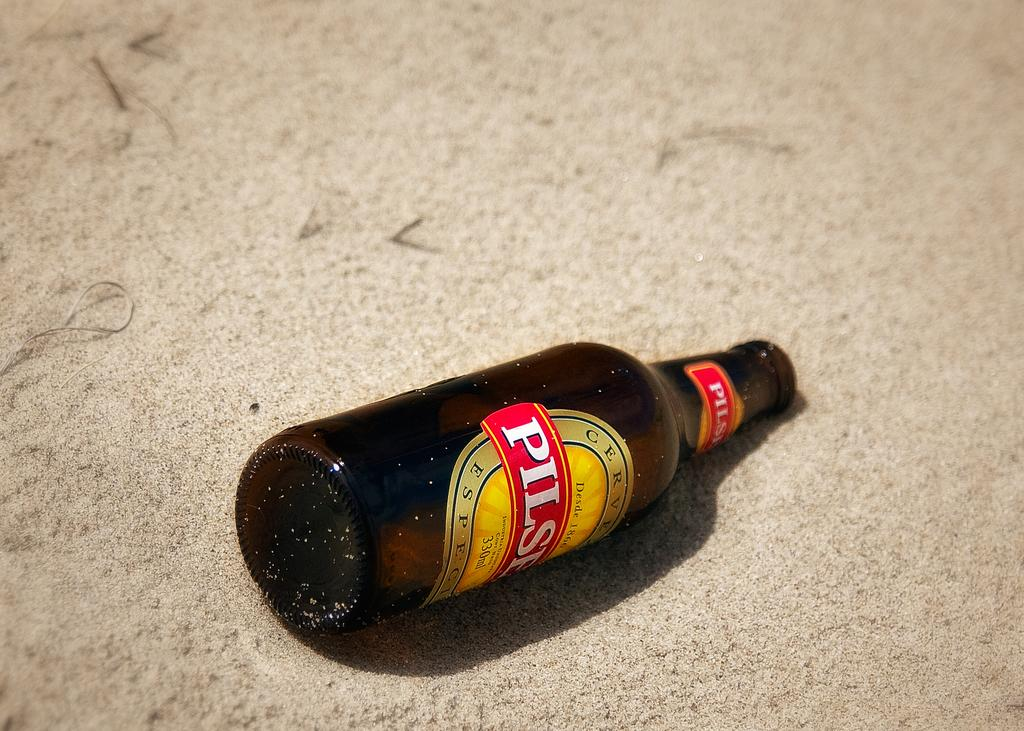<image>
Share a concise interpretation of the image provided. A lone bottle of Pilser is lying on the ground. 